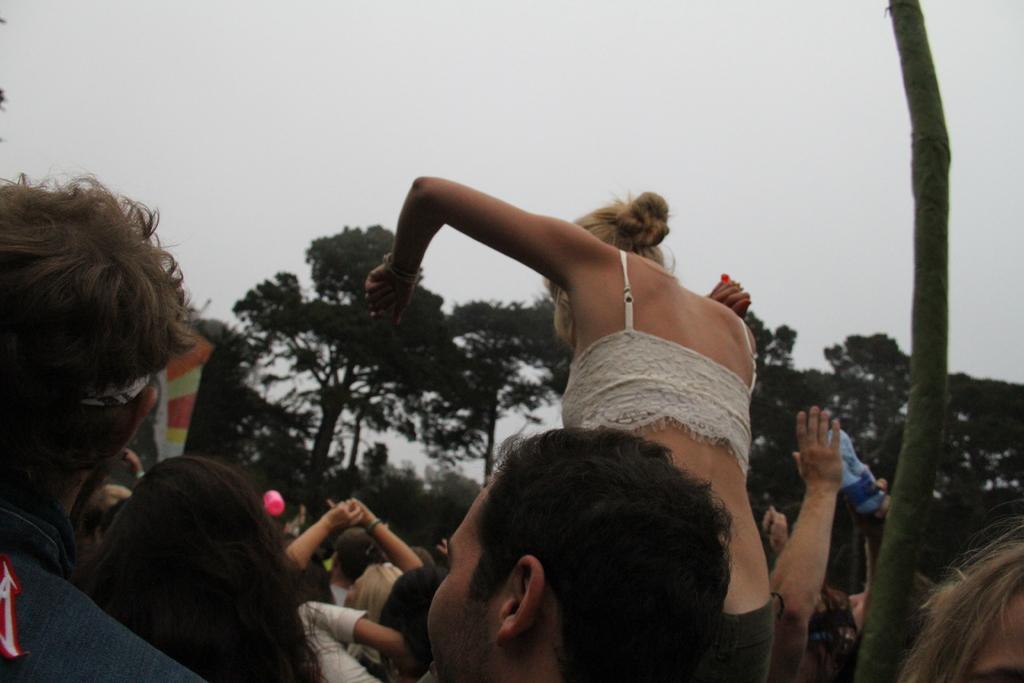Describe this image in one or two sentences. This image is taken outdoors. At the top of the image there is a sky. In the background there are many trees. In the middle of the image there are a few people. On the right side of the image there is a stick. 